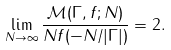<formula> <loc_0><loc_0><loc_500><loc_500>\lim _ { N \to \infty } \frac { \mathcal { M } ( \Gamma , f ; N ) } { N f ( - N / | \Gamma | ) } = 2 .</formula> 